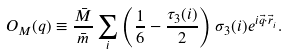<formula> <loc_0><loc_0><loc_500><loc_500>O _ { M } ( q ) \equiv \frac { \bar { M } } { \bar { m } } \sum _ { i } \left ( \frac { 1 } { 6 } - \frac { \tau _ { 3 } ( i ) } { 2 } \right ) \sigma _ { 3 } ( i ) e ^ { i \vec { q } \cdot \vec { r } _ { i } } .</formula> 